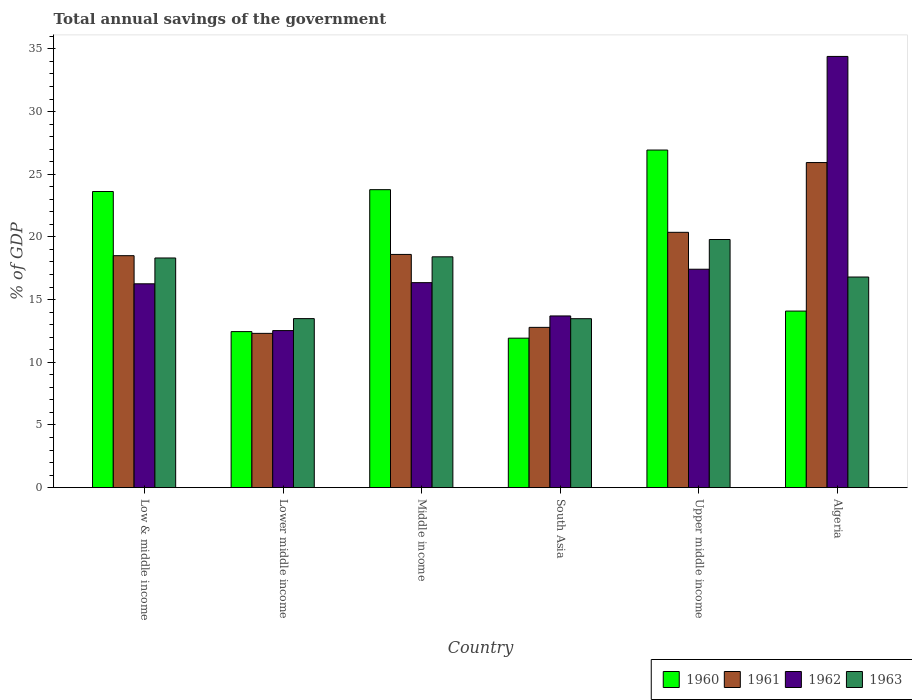How many different coloured bars are there?
Your response must be concise. 4. Are the number of bars per tick equal to the number of legend labels?
Provide a short and direct response. Yes. Are the number of bars on each tick of the X-axis equal?
Ensure brevity in your answer.  Yes. What is the label of the 2nd group of bars from the left?
Offer a terse response. Lower middle income. In how many cases, is the number of bars for a given country not equal to the number of legend labels?
Your response must be concise. 0. What is the total annual savings of the government in 1960 in Algeria?
Keep it short and to the point. 14.08. Across all countries, what is the maximum total annual savings of the government in 1963?
Offer a terse response. 19.79. Across all countries, what is the minimum total annual savings of the government in 1961?
Make the answer very short. 12.3. In which country was the total annual savings of the government in 1962 maximum?
Give a very brief answer. Algeria. In which country was the total annual savings of the government in 1960 minimum?
Offer a very short reply. South Asia. What is the total total annual savings of the government in 1961 in the graph?
Ensure brevity in your answer.  108.49. What is the difference between the total annual savings of the government in 1960 in Middle income and that in Upper middle income?
Keep it short and to the point. -3.16. What is the difference between the total annual savings of the government in 1960 in Middle income and the total annual savings of the government in 1961 in Upper middle income?
Provide a succinct answer. 3.4. What is the average total annual savings of the government in 1963 per country?
Your answer should be compact. 16.71. What is the difference between the total annual savings of the government of/in 1960 and total annual savings of the government of/in 1961 in Lower middle income?
Make the answer very short. 0.14. What is the ratio of the total annual savings of the government in 1962 in Algeria to that in Upper middle income?
Keep it short and to the point. 1.97. Is the total annual savings of the government in 1962 in Low & middle income less than that in Lower middle income?
Your answer should be very brief. No. What is the difference between the highest and the second highest total annual savings of the government in 1960?
Offer a terse response. 3.31. What is the difference between the highest and the lowest total annual savings of the government in 1961?
Give a very brief answer. 13.63. In how many countries, is the total annual savings of the government in 1963 greater than the average total annual savings of the government in 1963 taken over all countries?
Your answer should be very brief. 4. Is it the case that in every country, the sum of the total annual savings of the government in 1960 and total annual savings of the government in 1963 is greater than the sum of total annual savings of the government in 1961 and total annual savings of the government in 1962?
Ensure brevity in your answer.  No. What does the 4th bar from the right in Middle income represents?
Keep it short and to the point. 1960. How many bars are there?
Give a very brief answer. 24. What is the difference between two consecutive major ticks on the Y-axis?
Offer a very short reply. 5. Are the values on the major ticks of Y-axis written in scientific E-notation?
Offer a terse response. No. Does the graph contain any zero values?
Keep it short and to the point. No. How are the legend labels stacked?
Offer a terse response. Horizontal. What is the title of the graph?
Offer a very short reply. Total annual savings of the government. Does "1965" appear as one of the legend labels in the graph?
Provide a succinct answer. No. What is the label or title of the X-axis?
Provide a succinct answer. Country. What is the label or title of the Y-axis?
Offer a very short reply. % of GDP. What is the % of GDP in 1960 in Low & middle income?
Offer a terse response. 23.62. What is the % of GDP of 1961 in Low & middle income?
Make the answer very short. 18.5. What is the % of GDP in 1962 in Low & middle income?
Offer a very short reply. 16.26. What is the % of GDP in 1963 in Low & middle income?
Your answer should be very brief. 18.32. What is the % of GDP in 1960 in Lower middle income?
Offer a very short reply. 12.45. What is the % of GDP in 1961 in Lower middle income?
Your response must be concise. 12.3. What is the % of GDP in 1962 in Lower middle income?
Offer a terse response. 12.53. What is the % of GDP of 1963 in Lower middle income?
Your answer should be compact. 13.48. What is the % of GDP of 1960 in Middle income?
Make the answer very short. 23.77. What is the % of GDP in 1961 in Middle income?
Your answer should be very brief. 18.6. What is the % of GDP of 1962 in Middle income?
Offer a very short reply. 16.35. What is the % of GDP in 1963 in Middle income?
Provide a short and direct response. 18.41. What is the % of GDP in 1960 in South Asia?
Your response must be concise. 11.92. What is the % of GDP of 1961 in South Asia?
Give a very brief answer. 12.78. What is the % of GDP of 1962 in South Asia?
Provide a succinct answer. 13.69. What is the % of GDP of 1963 in South Asia?
Offer a very short reply. 13.48. What is the % of GDP of 1960 in Upper middle income?
Your answer should be compact. 26.93. What is the % of GDP in 1961 in Upper middle income?
Provide a succinct answer. 20.37. What is the % of GDP in 1962 in Upper middle income?
Provide a short and direct response. 17.42. What is the % of GDP of 1963 in Upper middle income?
Provide a succinct answer. 19.79. What is the % of GDP in 1960 in Algeria?
Offer a very short reply. 14.08. What is the % of GDP in 1961 in Algeria?
Keep it short and to the point. 25.93. What is the % of GDP of 1962 in Algeria?
Your response must be concise. 34.4. What is the % of GDP in 1963 in Algeria?
Your answer should be very brief. 16.8. Across all countries, what is the maximum % of GDP in 1960?
Your answer should be compact. 26.93. Across all countries, what is the maximum % of GDP of 1961?
Your answer should be compact. 25.93. Across all countries, what is the maximum % of GDP in 1962?
Offer a very short reply. 34.4. Across all countries, what is the maximum % of GDP in 1963?
Make the answer very short. 19.79. Across all countries, what is the minimum % of GDP of 1960?
Your answer should be very brief. 11.92. Across all countries, what is the minimum % of GDP in 1961?
Your response must be concise. 12.3. Across all countries, what is the minimum % of GDP in 1962?
Your answer should be compact. 12.53. Across all countries, what is the minimum % of GDP of 1963?
Keep it short and to the point. 13.48. What is the total % of GDP of 1960 in the graph?
Provide a short and direct response. 112.77. What is the total % of GDP in 1961 in the graph?
Keep it short and to the point. 108.49. What is the total % of GDP in 1962 in the graph?
Keep it short and to the point. 110.65. What is the total % of GDP of 1963 in the graph?
Your answer should be compact. 100.28. What is the difference between the % of GDP in 1960 in Low & middle income and that in Lower middle income?
Provide a short and direct response. 11.18. What is the difference between the % of GDP in 1961 in Low & middle income and that in Lower middle income?
Ensure brevity in your answer.  6.2. What is the difference between the % of GDP of 1962 in Low & middle income and that in Lower middle income?
Your answer should be very brief. 3.73. What is the difference between the % of GDP in 1963 in Low & middle income and that in Lower middle income?
Provide a short and direct response. 4.84. What is the difference between the % of GDP in 1960 in Low & middle income and that in Middle income?
Your answer should be compact. -0.15. What is the difference between the % of GDP in 1961 in Low & middle income and that in Middle income?
Offer a terse response. -0.1. What is the difference between the % of GDP in 1962 in Low & middle income and that in Middle income?
Ensure brevity in your answer.  -0.09. What is the difference between the % of GDP of 1963 in Low & middle income and that in Middle income?
Your answer should be compact. -0.09. What is the difference between the % of GDP of 1960 in Low & middle income and that in South Asia?
Your response must be concise. 11.7. What is the difference between the % of GDP of 1961 in Low & middle income and that in South Asia?
Provide a succinct answer. 5.72. What is the difference between the % of GDP of 1962 in Low & middle income and that in South Asia?
Provide a succinct answer. 2.56. What is the difference between the % of GDP of 1963 in Low & middle income and that in South Asia?
Provide a succinct answer. 4.84. What is the difference between the % of GDP in 1960 in Low & middle income and that in Upper middle income?
Offer a very short reply. -3.31. What is the difference between the % of GDP in 1961 in Low & middle income and that in Upper middle income?
Offer a terse response. -1.86. What is the difference between the % of GDP of 1962 in Low & middle income and that in Upper middle income?
Keep it short and to the point. -1.16. What is the difference between the % of GDP in 1963 in Low & middle income and that in Upper middle income?
Give a very brief answer. -1.47. What is the difference between the % of GDP in 1960 in Low & middle income and that in Algeria?
Provide a short and direct response. 9.54. What is the difference between the % of GDP in 1961 in Low & middle income and that in Algeria?
Your answer should be very brief. -7.43. What is the difference between the % of GDP of 1962 in Low & middle income and that in Algeria?
Your answer should be very brief. -18.14. What is the difference between the % of GDP in 1963 in Low & middle income and that in Algeria?
Ensure brevity in your answer.  1.52. What is the difference between the % of GDP of 1960 in Lower middle income and that in Middle income?
Offer a very short reply. -11.32. What is the difference between the % of GDP of 1961 in Lower middle income and that in Middle income?
Your answer should be compact. -6.3. What is the difference between the % of GDP in 1962 in Lower middle income and that in Middle income?
Ensure brevity in your answer.  -3.82. What is the difference between the % of GDP in 1963 in Lower middle income and that in Middle income?
Ensure brevity in your answer.  -4.93. What is the difference between the % of GDP in 1960 in Lower middle income and that in South Asia?
Make the answer very short. 0.52. What is the difference between the % of GDP of 1961 in Lower middle income and that in South Asia?
Ensure brevity in your answer.  -0.48. What is the difference between the % of GDP of 1962 in Lower middle income and that in South Asia?
Offer a very short reply. -1.17. What is the difference between the % of GDP in 1963 in Lower middle income and that in South Asia?
Give a very brief answer. 0.01. What is the difference between the % of GDP of 1960 in Lower middle income and that in Upper middle income?
Offer a very short reply. -14.48. What is the difference between the % of GDP in 1961 in Lower middle income and that in Upper middle income?
Offer a terse response. -8.06. What is the difference between the % of GDP in 1962 in Lower middle income and that in Upper middle income?
Your response must be concise. -4.89. What is the difference between the % of GDP of 1963 in Lower middle income and that in Upper middle income?
Your answer should be compact. -6.31. What is the difference between the % of GDP of 1960 in Lower middle income and that in Algeria?
Your response must be concise. -1.64. What is the difference between the % of GDP of 1961 in Lower middle income and that in Algeria?
Your answer should be very brief. -13.63. What is the difference between the % of GDP of 1962 in Lower middle income and that in Algeria?
Give a very brief answer. -21.87. What is the difference between the % of GDP in 1963 in Lower middle income and that in Algeria?
Offer a terse response. -3.32. What is the difference between the % of GDP in 1960 in Middle income and that in South Asia?
Provide a short and direct response. 11.85. What is the difference between the % of GDP in 1961 in Middle income and that in South Asia?
Make the answer very short. 5.82. What is the difference between the % of GDP of 1962 in Middle income and that in South Asia?
Offer a very short reply. 2.66. What is the difference between the % of GDP of 1963 in Middle income and that in South Asia?
Offer a very short reply. 4.94. What is the difference between the % of GDP of 1960 in Middle income and that in Upper middle income?
Make the answer very short. -3.16. What is the difference between the % of GDP of 1961 in Middle income and that in Upper middle income?
Make the answer very short. -1.76. What is the difference between the % of GDP in 1962 in Middle income and that in Upper middle income?
Your response must be concise. -1.07. What is the difference between the % of GDP in 1963 in Middle income and that in Upper middle income?
Offer a terse response. -1.38. What is the difference between the % of GDP in 1960 in Middle income and that in Algeria?
Provide a succinct answer. 9.68. What is the difference between the % of GDP of 1961 in Middle income and that in Algeria?
Your answer should be compact. -7.33. What is the difference between the % of GDP in 1962 in Middle income and that in Algeria?
Ensure brevity in your answer.  -18.05. What is the difference between the % of GDP of 1963 in Middle income and that in Algeria?
Provide a succinct answer. 1.61. What is the difference between the % of GDP in 1960 in South Asia and that in Upper middle income?
Ensure brevity in your answer.  -15.01. What is the difference between the % of GDP in 1961 in South Asia and that in Upper middle income?
Your answer should be very brief. -7.58. What is the difference between the % of GDP of 1962 in South Asia and that in Upper middle income?
Keep it short and to the point. -3.73. What is the difference between the % of GDP in 1963 in South Asia and that in Upper middle income?
Offer a terse response. -6.32. What is the difference between the % of GDP of 1960 in South Asia and that in Algeria?
Offer a terse response. -2.16. What is the difference between the % of GDP in 1961 in South Asia and that in Algeria?
Ensure brevity in your answer.  -13.15. What is the difference between the % of GDP in 1962 in South Asia and that in Algeria?
Provide a short and direct response. -20.7. What is the difference between the % of GDP of 1963 in South Asia and that in Algeria?
Offer a terse response. -3.32. What is the difference between the % of GDP in 1960 in Upper middle income and that in Algeria?
Keep it short and to the point. 12.84. What is the difference between the % of GDP in 1961 in Upper middle income and that in Algeria?
Make the answer very short. -5.57. What is the difference between the % of GDP in 1962 in Upper middle income and that in Algeria?
Make the answer very short. -16.97. What is the difference between the % of GDP of 1963 in Upper middle income and that in Algeria?
Give a very brief answer. 2.99. What is the difference between the % of GDP in 1960 in Low & middle income and the % of GDP in 1961 in Lower middle income?
Make the answer very short. 11.32. What is the difference between the % of GDP of 1960 in Low & middle income and the % of GDP of 1962 in Lower middle income?
Provide a short and direct response. 11.09. What is the difference between the % of GDP in 1960 in Low & middle income and the % of GDP in 1963 in Lower middle income?
Your answer should be very brief. 10.14. What is the difference between the % of GDP in 1961 in Low & middle income and the % of GDP in 1962 in Lower middle income?
Give a very brief answer. 5.97. What is the difference between the % of GDP in 1961 in Low & middle income and the % of GDP in 1963 in Lower middle income?
Provide a short and direct response. 5.02. What is the difference between the % of GDP in 1962 in Low & middle income and the % of GDP in 1963 in Lower middle income?
Keep it short and to the point. 2.78. What is the difference between the % of GDP in 1960 in Low & middle income and the % of GDP in 1961 in Middle income?
Your response must be concise. 5.02. What is the difference between the % of GDP in 1960 in Low & middle income and the % of GDP in 1962 in Middle income?
Provide a short and direct response. 7.27. What is the difference between the % of GDP in 1960 in Low & middle income and the % of GDP in 1963 in Middle income?
Keep it short and to the point. 5.21. What is the difference between the % of GDP in 1961 in Low & middle income and the % of GDP in 1962 in Middle income?
Give a very brief answer. 2.15. What is the difference between the % of GDP of 1961 in Low & middle income and the % of GDP of 1963 in Middle income?
Provide a short and direct response. 0.09. What is the difference between the % of GDP in 1962 in Low & middle income and the % of GDP in 1963 in Middle income?
Your response must be concise. -2.15. What is the difference between the % of GDP of 1960 in Low & middle income and the % of GDP of 1961 in South Asia?
Keep it short and to the point. 10.84. What is the difference between the % of GDP in 1960 in Low & middle income and the % of GDP in 1962 in South Asia?
Give a very brief answer. 9.93. What is the difference between the % of GDP of 1960 in Low & middle income and the % of GDP of 1963 in South Asia?
Offer a very short reply. 10.15. What is the difference between the % of GDP in 1961 in Low & middle income and the % of GDP in 1962 in South Asia?
Provide a succinct answer. 4.81. What is the difference between the % of GDP of 1961 in Low & middle income and the % of GDP of 1963 in South Asia?
Keep it short and to the point. 5.03. What is the difference between the % of GDP in 1962 in Low & middle income and the % of GDP in 1963 in South Asia?
Offer a terse response. 2.78. What is the difference between the % of GDP of 1960 in Low & middle income and the % of GDP of 1961 in Upper middle income?
Provide a succinct answer. 3.26. What is the difference between the % of GDP in 1960 in Low & middle income and the % of GDP in 1962 in Upper middle income?
Provide a succinct answer. 6.2. What is the difference between the % of GDP in 1960 in Low & middle income and the % of GDP in 1963 in Upper middle income?
Keep it short and to the point. 3.83. What is the difference between the % of GDP of 1961 in Low & middle income and the % of GDP of 1962 in Upper middle income?
Offer a terse response. 1.08. What is the difference between the % of GDP in 1961 in Low & middle income and the % of GDP in 1963 in Upper middle income?
Ensure brevity in your answer.  -1.29. What is the difference between the % of GDP in 1962 in Low & middle income and the % of GDP in 1963 in Upper middle income?
Your response must be concise. -3.53. What is the difference between the % of GDP in 1960 in Low & middle income and the % of GDP in 1961 in Algeria?
Give a very brief answer. -2.31. What is the difference between the % of GDP in 1960 in Low & middle income and the % of GDP in 1962 in Algeria?
Ensure brevity in your answer.  -10.77. What is the difference between the % of GDP in 1960 in Low & middle income and the % of GDP in 1963 in Algeria?
Offer a very short reply. 6.82. What is the difference between the % of GDP of 1961 in Low & middle income and the % of GDP of 1962 in Algeria?
Offer a terse response. -15.89. What is the difference between the % of GDP in 1961 in Low & middle income and the % of GDP in 1963 in Algeria?
Your response must be concise. 1.7. What is the difference between the % of GDP in 1962 in Low & middle income and the % of GDP in 1963 in Algeria?
Your answer should be very brief. -0.54. What is the difference between the % of GDP of 1960 in Lower middle income and the % of GDP of 1961 in Middle income?
Your answer should be very brief. -6.16. What is the difference between the % of GDP of 1960 in Lower middle income and the % of GDP of 1962 in Middle income?
Ensure brevity in your answer.  -3.9. What is the difference between the % of GDP in 1960 in Lower middle income and the % of GDP in 1963 in Middle income?
Your response must be concise. -5.97. What is the difference between the % of GDP of 1961 in Lower middle income and the % of GDP of 1962 in Middle income?
Your answer should be very brief. -4.05. What is the difference between the % of GDP of 1961 in Lower middle income and the % of GDP of 1963 in Middle income?
Give a very brief answer. -6.11. What is the difference between the % of GDP of 1962 in Lower middle income and the % of GDP of 1963 in Middle income?
Offer a very short reply. -5.88. What is the difference between the % of GDP in 1960 in Lower middle income and the % of GDP in 1961 in South Asia?
Your answer should be very brief. -0.34. What is the difference between the % of GDP of 1960 in Lower middle income and the % of GDP of 1962 in South Asia?
Ensure brevity in your answer.  -1.25. What is the difference between the % of GDP of 1960 in Lower middle income and the % of GDP of 1963 in South Asia?
Offer a very short reply. -1.03. What is the difference between the % of GDP in 1961 in Lower middle income and the % of GDP in 1962 in South Asia?
Your answer should be very brief. -1.39. What is the difference between the % of GDP in 1961 in Lower middle income and the % of GDP in 1963 in South Asia?
Your response must be concise. -1.17. What is the difference between the % of GDP of 1962 in Lower middle income and the % of GDP of 1963 in South Asia?
Make the answer very short. -0.95. What is the difference between the % of GDP of 1960 in Lower middle income and the % of GDP of 1961 in Upper middle income?
Provide a succinct answer. -7.92. What is the difference between the % of GDP of 1960 in Lower middle income and the % of GDP of 1962 in Upper middle income?
Your answer should be very brief. -4.98. What is the difference between the % of GDP of 1960 in Lower middle income and the % of GDP of 1963 in Upper middle income?
Your answer should be compact. -7.35. What is the difference between the % of GDP in 1961 in Lower middle income and the % of GDP in 1962 in Upper middle income?
Give a very brief answer. -5.12. What is the difference between the % of GDP of 1961 in Lower middle income and the % of GDP of 1963 in Upper middle income?
Your answer should be very brief. -7.49. What is the difference between the % of GDP of 1962 in Lower middle income and the % of GDP of 1963 in Upper middle income?
Keep it short and to the point. -7.26. What is the difference between the % of GDP in 1960 in Lower middle income and the % of GDP in 1961 in Algeria?
Your response must be concise. -13.48. What is the difference between the % of GDP in 1960 in Lower middle income and the % of GDP in 1962 in Algeria?
Ensure brevity in your answer.  -21.95. What is the difference between the % of GDP of 1960 in Lower middle income and the % of GDP of 1963 in Algeria?
Provide a succinct answer. -4.35. What is the difference between the % of GDP in 1961 in Lower middle income and the % of GDP in 1962 in Algeria?
Your response must be concise. -22.09. What is the difference between the % of GDP of 1961 in Lower middle income and the % of GDP of 1963 in Algeria?
Provide a succinct answer. -4.5. What is the difference between the % of GDP of 1962 in Lower middle income and the % of GDP of 1963 in Algeria?
Keep it short and to the point. -4.27. What is the difference between the % of GDP of 1960 in Middle income and the % of GDP of 1961 in South Asia?
Your answer should be very brief. 10.98. What is the difference between the % of GDP in 1960 in Middle income and the % of GDP in 1962 in South Asia?
Your response must be concise. 10.07. What is the difference between the % of GDP in 1960 in Middle income and the % of GDP in 1963 in South Asia?
Offer a terse response. 10.29. What is the difference between the % of GDP in 1961 in Middle income and the % of GDP in 1962 in South Asia?
Provide a succinct answer. 4.91. What is the difference between the % of GDP in 1961 in Middle income and the % of GDP in 1963 in South Asia?
Your response must be concise. 5.13. What is the difference between the % of GDP in 1962 in Middle income and the % of GDP in 1963 in South Asia?
Give a very brief answer. 2.88. What is the difference between the % of GDP of 1960 in Middle income and the % of GDP of 1961 in Upper middle income?
Ensure brevity in your answer.  3.4. What is the difference between the % of GDP in 1960 in Middle income and the % of GDP in 1962 in Upper middle income?
Ensure brevity in your answer.  6.35. What is the difference between the % of GDP of 1960 in Middle income and the % of GDP of 1963 in Upper middle income?
Provide a short and direct response. 3.98. What is the difference between the % of GDP of 1961 in Middle income and the % of GDP of 1962 in Upper middle income?
Offer a terse response. 1.18. What is the difference between the % of GDP in 1961 in Middle income and the % of GDP in 1963 in Upper middle income?
Your answer should be very brief. -1.19. What is the difference between the % of GDP in 1962 in Middle income and the % of GDP in 1963 in Upper middle income?
Provide a short and direct response. -3.44. What is the difference between the % of GDP of 1960 in Middle income and the % of GDP of 1961 in Algeria?
Ensure brevity in your answer.  -2.16. What is the difference between the % of GDP of 1960 in Middle income and the % of GDP of 1962 in Algeria?
Provide a succinct answer. -10.63. What is the difference between the % of GDP of 1960 in Middle income and the % of GDP of 1963 in Algeria?
Ensure brevity in your answer.  6.97. What is the difference between the % of GDP of 1961 in Middle income and the % of GDP of 1962 in Algeria?
Ensure brevity in your answer.  -15.79. What is the difference between the % of GDP of 1961 in Middle income and the % of GDP of 1963 in Algeria?
Your answer should be compact. 1.8. What is the difference between the % of GDP of 1962 in Middle income and the % of GDP of 1963 in Algeria?
Offer a very short reply. -0.45. What is the difference between the % of GDP in 1960 in South Asia and the % of GDP in 1961 in Upper middle income?
Ensure brevity in your answer.  -8.44. What is the difference between the % of GDP in 1960 in South Asia and the % of GDP in 1962 in Upper middle income?
Make the answer very short. -5.5. What is the difference between the % of GDP of 1960 in South Asia and the % of GDP of 1963 in Upper middle income?
Offer a terse response. -7.87. What is the difference between the % of GDP in 1961 in South Asia and the % of GDP in 1962 in Upper middle income?
Your answer should be compact. -4.64. What is the difference between the % of GDP in 1961 in South Asia and the % of GDP in 1963 in Upper middle income?
Provide a succinct answer. -7.01. What is the difference between the % of GDP of 1962 in South Asia and the % of GDP of 1963 in Upper middle income?
Offer a very short reply. -6.1. What is the difference between the % of GDP of 1960 in South Asia and the % of GDP of 1961 in Algeria?
Provide a succinct answer. -14.01. What is the difference between the % of GDP of 1960 in South Asia and the % of GDP of 1962 in Algeria?
Provide a short and direct response. -22.47. What is the difference between the % of GDP in 1960 in South Asia and the % of GDP in 1963 in Algeria?
Keep it short and to the point. -4.88. What is the difference between the % of GDP in 1961 in South Asia and the % of GDP in 1962 in Algeria?
Give a very brief answer. -21.61. What is the difference between the % of GDP of 1961 in South Asia and the % of GDP of 1963 in Algeria?
Give a very brief answer. -4.02. What is the difference between the % of GDP of 1962 in South Asia and the % of GDP of 1963 in Algeria?
Ensure brevity in your answer.  -3.1. What is the difference between the % of GDP of 1960 in Upper middle income and the % of GDP of 1962 in Algeria?
Ensure brevity in your answer.  -7.47. What is the difference between the % of GDP in 1960 in Upper middle income and the % of GDP in 1963 in Algeria?
Offer a very short reply. 10.13. What is the difference between the % of GDP of 1961 in Upper middle income and the % of GDP of 1962 in Algeria?
Keep it short and to the point. -14.03. What is the difference between the % of GDP in 1961 in Upper middle income and the % of GDP in 1963 in Algeria?
Provide a succinct answer. 3.57. What is the difference between the % of GDP in 1962 in Upper middle income and the % of GDP in 1963 in Algeria?
Your answer should be compact. 0.62. What is the average % of GDP of 1960 per country?
Offer a very short reply. 18.8. What is the average % of GDP in 1961 per country?
Keep it short and to the point. 18.08. What is the average % of GDP in 1962 per country?
Provide a short and direct response. 18.44. What is the average % of GDP in 1963 per country?
Offer a terse response. 16.71. What is the difference between the % of GDP of 1960 and % of GDP of 1961 in Low & middle income?
Offer a terse response. 5.12. What is the difference between the % of GDP in 1960 and % of GDP in 1962 in Low & middle income?
Your answer should be compact. 7.36. What is the difference between the % of GDP in 1960 and % of GDP in 1963 in Low & middle income?
Your answer should be compact. 5.3. What is the difference between the % of GDP of 1961 and % of GDP of 1962 in Low & middle income?
Offer a terse response. 2.24. What is the difference between the % of GDP of 1961 and % of GDP of 1963 in Low & middle income?
Ensure brevity in your answer.  0.18. What is the difference between the % of GDP of 1962 and % of GDP of 1963 in Low & middle income?
Offer a terse response. -2.06. What is the difference between the % of GDP of 1960 and % of GDP of 1961 in Lower middle income?
Make the answer very short. 0.14. What is the difference between the % of GDP of 1960 and % of GDP of 1962 in Lower middle income?
Offer a terse response. -0.08. What is the difference between the % of GDP of 1960 and % of GDP of 1963 in Lower middle income?
Provide a short and direct response. -1.04. What is the difference between the % of GDP in 1961 and % of GDP in 1962 in Lower middle income?
Make the answer very short. -0.22. What is the difference between the % of GDP in 1961 and % of GDP in 1963 in Lower middle income?
Your answer should be compact. -1.18. What is the difference between the % of GDP in 1962 and % of GDP in 1963 in Lower middle income?
Ensure brevity in your answer.  -0.95. What is the difference between the % of GDP of 1960 and % of GDP of 1961 in Middle income?
Your response must be concise. 5.17. What is the difference between the % of GDP of 1960 and % of GDP of 1962 in Middle income?
Your response must be concise. 7.42. What is the difference between the % of GDP of 1960 and % of GDP of 1963 in Middle income?
Make the answer very short. 5.36. What is the difference between the % of GDP of 1961 and % of GDP of 1962 in Middle income?
Make the answer very short. 2.25. What is the difference between the % of GDP in 1961 and % of GDP in 1963 in Middle income?
Keep it short and to the point. 0.19. What is the difference between the % of GDP in 1962 and % of GDP in 1963 in Middle income?
Make the answer very short. -2.06. What is the difference between the % of GDP of 1960 and % of GDP of 1961 in South Asia?
Keep it short and to the point. -0.86. What is the difference between the % of GDP of 1960 and % of GDP of 1962 in South Asia?
Provide a succinct answer. -1.77. What is the difference between the % of GDP of 1960 and % of GDP of 1963 in South Asia?
Make the answer very short. -1.55. What is the difference between the % of GDP of 1961 and % of GDP of 1962 in South Asia?
Make the answer very short. -0.91. What is the difference between the % of GDP in 1961 and % of GDP in 1963 in South Asia?
Offer a very short reply. -0.69. What is the difference between the % of GDP of 1962 and % of GDP of 1963 in South Asia?
Provide a short and direct response. 0.22. What is the difference between the % of GDP of 1960 and % of GDP of 1961 in Upper middle income?
Make the answer very short. 6.56. What is the difference between the % of GDP of 1960 and % of GDP of 1962 in Upper middle income?
Offer a terse response. 9.51. What is the difference between the % of GDP in 1960 and % of GDP in 1963 in Upper middle income?
Offer a terse response. 7.14. What is the difference between the % of GDP of 1961 and % of GDP of 1962 in Upper middle income?
Provide a succinct answer. 2.94. What is the difference between the % of GDP in 1961 and % of GDP in 1963 in Upper middle income?
Ensure brevity in your answer.  0.57. What is the difference between the % of GDP in 1962 and % of GDP in 1963 in Upper middle income?
Offer a terse response. -2.37. What is the difference between the % of GDP in 1960 and % of GDP in 1961 in Algeria?
Provide a short and direct response. -11.85. What is the difference between the % of GDP in 1960 and % of GDP in 1962 in Algeria?
Offer a terse response. -20.31. What is the difference between the % of GDP of 1960 and % of GDP of 1963 in Algeria?
Keep it short and to the point. -2.72. What is the difference between the % of GDP of 1961 and % of GDP of 1962 in Algeria?
Provide a short and direct response. -8.47. What is the difference between the % of GDP in 1961 and % of GDP in 1963 in Algeria?
Give a very brief answer. 9.13. What is the difference between the % of GDP in 1962 and % of GDP in 1963 in Algeria?
Ensure brevity in your answer.  17.6. What is the ratio of the % of GDP in 1960 in Low & middle income to that in Lower middle income?
Provide a short and direct response. 1.9. What is the ratio of the % of GDP in 1961 in Low & middle income to that in Lower middle income?
Offer a very short reply. 1.5. What is the ratio of the % of GDP of 1962 in Low & middle income to that in Lower middle income?
Offer a very short reply. 1.3. What is the ratio of the % of GDP of 1963 in Low & middle income to that in Lower middle income?
Ensure brevity in your answer.  1.36. What is the ratio of the % of GDP of 1960 in Low & middle income to that in Middle income?
Your response must be concise. 0.99. What is the ratio of the % of GDP of 1961 in Low & middle income to that in Middle income?
Give a very brief answer. 0.99. What is the ratio of the % of GDP of 1962 in Low & middle income to that in Middle income?
Give a very brief answer. 0.99. What is the ratio of the % of GDP of 1960 in Low & middle income to that in South Asia?
Offer a terse response. 1.98. What is the ratio of the % of GDP of 1961 in Low & middle income to that in South Asia?
Offer a terse response. 1.45. What is the ratio of the % of GDP in 1962 in Low & middle income to that in South Asia?
Provide a short and direct response. 1.19. What is the ratio of the % of GDP of 1963 in Low & middle income to that in South Asia?
Your answer should be compact. 1.36. What is the ratio of the % of GDP in 1960 in Low & middle income to that in Upper middle income?
Provide a short and direct response. 0.88. What is the ratio of the % of GDP of 1961 in Low & middle income to that in Upper middle income?
Provide a short and direct response. 0.91. What is the ratio of the % of GDP in 1962 in Low & middle income to that in Upper middle income?
Offer a terse response. 0.93. What is the ratio of the % of GDP of 1963 in Low & middle income to that in Upper middle income?
Keep it short and to the point. 0.93. What is the ratio of the % of GDP in 1960 in Low & middle income to that in Algeria?
Provide a succinct answer. 1.68. What is the ratio of the % of GDP of 1961 in Low & middle income to that in Algeria?
Make the answer very short. 0.71. What is the ratio of the % of GDP of 1962 in Low & middle income to that in Algeria?
Provide a short and direct response. 0.47. What is the ratio of the % of GDP of 1963 in Low & middle income to that in Algeria?
Your answer should be very brief. 1.09. What is the ratio of the % of GDP in 1960 in Lower middle income to that in Middle income?
Provide a short and direct response. 0.52. What is the ratio of the % of GDP of 1961 in Lower middle income to that in Middle income?
Provide a succinct answer. 0.66. What is the ratio of the % of GDP of 1962 in Lower middle income to that in Middle income?
Offer a very short reply. 0.77. What is the ratio of the % of GDP of 1963 in Lower middle income to that in Middle income?
Give a very brief answer. 0.73. What is the ratio of the % of GDP of 1960 in Lower middle income to that in South Asia?
Offer a very short reply. 1.04. What is the ratio of the % of GDP of 1961 in Lower middle income to that in South Asia?
Keep it short and to the point. 0.96. What is the ratio of the % of GDP of 1962 in Lower middle income to that in South Asia?
Your answer should be very brief. 0.91. What is the ratio of the % of GDP in 1963 in Lower middle income to that in South Asia?
Ensure brevity in your answer.  1. What is the ratio of the % of GDP of 1960 in Lower middle income to that in Upper middle income?
Make the answer very short. 0.46. What is the ratio of the % of GDP in 1961 in Lower middle income to that in Upper middle income?
Your response must be concise. 0.6. What is the ratio of the % of GDP in 1962 in Lower middle income to that in Upper middle income?
Give a very brief answer. 0.72. What is the ratio of the % of GDP of 1963 in Lower middle income to that in Upper middle income?
Keep it short and to the point. 0.68. What is the ratio of the % of GDP of 1960 in Lower middle income to that in Algeria?
Your response must be concise. 0.88. What is the ratio of the % of GDP in 1961 in Lower middle income to that in Algeria?
Your answer should be compact. 0.47. What is the ratio of the % of GDP in 1962 in Lower middle income to that in Algeria?
Keep it short and to the point. 0.36. What is the ratio of the % of GDP of 1963 in Lower middle income to that in Algeria?
Your response must be concise. 0.8. What is the ratio of the % of GDP in 1960 in Middle income to that in South Asia?
Provide a succinct answer. 1.99. What is the ratio of the % of GDP in 1961 in Middle income to that in South Asia?
Your answer should be compact. 1.46. What is the ratio of the % of GDP of 1962 in Middle income to that in South Asia?
Offer a very short reply. 1.19. What is the ratio of the % of GDP in 1963 in Middle income to that in South Asia?
Offer a terse response. 1.37. What is the ratio of the % of GDP in 1960 in Middle income to that in Upper middle income?
Offer a very short reply. 0.88. What is the ratio of the % of GDP of 1961 in Middle income to that in Upper middle income?
Your answer should be compact. 0.91. What is the ratio of the % of GDP of 1962 in Middle income to that in Upper middle income?
Your response must be concise. 0.94. What is the ratio of the % of GDP of 1963 in Middle income to that in Upper middle income?
Keep it short and to the point. 0.93. What is the ratio of the % of GDP in 1960 in Middle income to that in Algeria?
Offer a very short reply. 1.69. What is the ratio of the % of GDP in 1961 in Middle income to that in Algeria?
Offer a terse response. 0.72. What is the ratio of the % of GDP in 1962 in Middle income to that in Algeria?
Offer a very short reply. 0.48. What is the ratio of the % of GDP in 1963 in Middle income to that in Algeria?
Offer a terse response. 1.1. What is the ratio of the % of GDP of 1960 in South Asia to that in Upper middle income?
Offer a very short reply. 0.44. What is the ratio of the % of GDP of 1961 in South Asia to that in Upper middle income?
Provide a short and direct response. 0.63. What is the ratio of the % of GDP of 1962 in South Asia to that in Upper middle income?
Provide a short and direct response. 0.79. What is the ratio of the % of GDP in 1963 in South Asia to that in Upper middle income?
Keep it short and to the point. 0.68. What is the ratio of the % of GDP of 1960 in South Asia to that in Algeria?
Your answer should be compact. 0.85. What is the ratio of the % of GDP in 1961 in South Asia to that in Algeria?
Offer a terse response. 0.49. What is the ratio of the % of GDP of 1962 in South Asia to that in Algeria?
Your response must be concise. 0.4. What is the ratio of the % of GDP in 1963 in South Asia to that in Algeria?
Your response must be concise. 0.8. What is the ratio of the % of GDP of 1960 in Upper middle income to that in Algeria?
Your response must be concise. 1.91. What is the ratio of the % of GDP of 1961 in Upper middle income to that in Algeria?
Your answer should be compact. 0.79. What is the ratio of the % of GDP of 1962 in Upper middle income to that in Algeria?
Your answer should be very brief. 0.51. What is the ratio of the % of GDP in 1963 in Upper middle income to that in Algeria?
Provide a succinct answer. 1.18. What is the difference between the highest and the second highest % of GDP of 1960?
Your answer should be very brief. 3.16. What is the difference between the highest and the second highest % of GDP of 1961?
Your response must be concise. 5.57. What is the difference between the highest and the second highest % of GDP in 1962?
Keep it short and to the point. 16.97. What is the difference between the highest and the second highest % of GDP in 1963?
Ensure brevity in your answer.  1.38. What is the difference between the highest and the lowest % of GDP of 1960?
Provide a succinct answer. 15.01. What is the difference between the highest and the lowest % of GDP of 1961?
Your response must be concise. 13.63. What is the difference between the highest and the lowest % of GDP in 1962?
Ensure brevity in your answer.  21.87. What is the difference between the highest and the lowest % of GDP of 1963?
Provide a succinct answer. 6.32. 